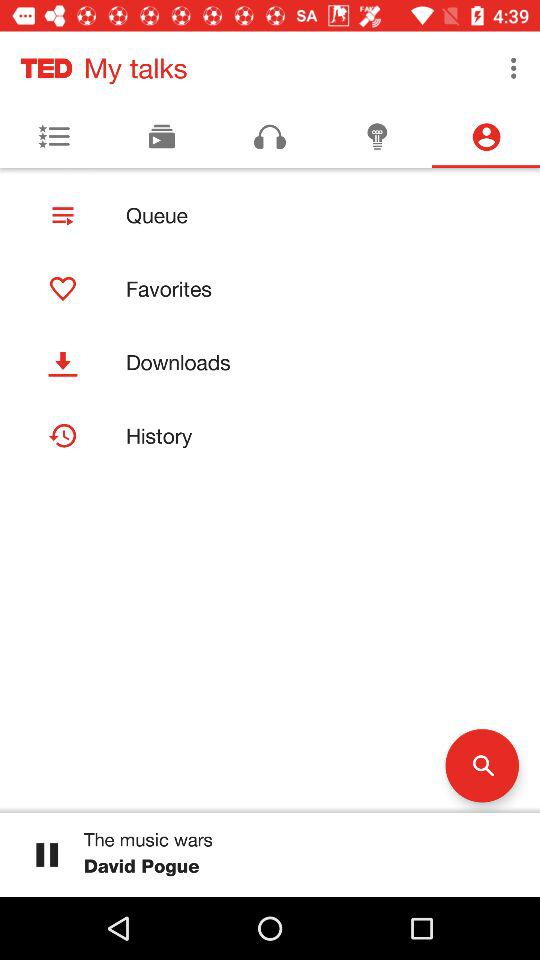What is the application name? The application name is "TED My talks". 